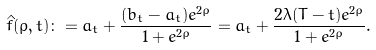<formula> <loc_0><loc_0><loc_500><loc_500>\hat { f } ( \rho , t ) \colon = a _ { t } + \frac { ( b _ { t } - a _ { t } ) e ^ { 2 \rho } } { 1 + e ^ { 2 \rho } } = a _ { t } + \frac { 2 \lambda ( T - t ) e ^ { 2 \rho } } { 1 + e ^ { 2 \rho } } .</formula> 